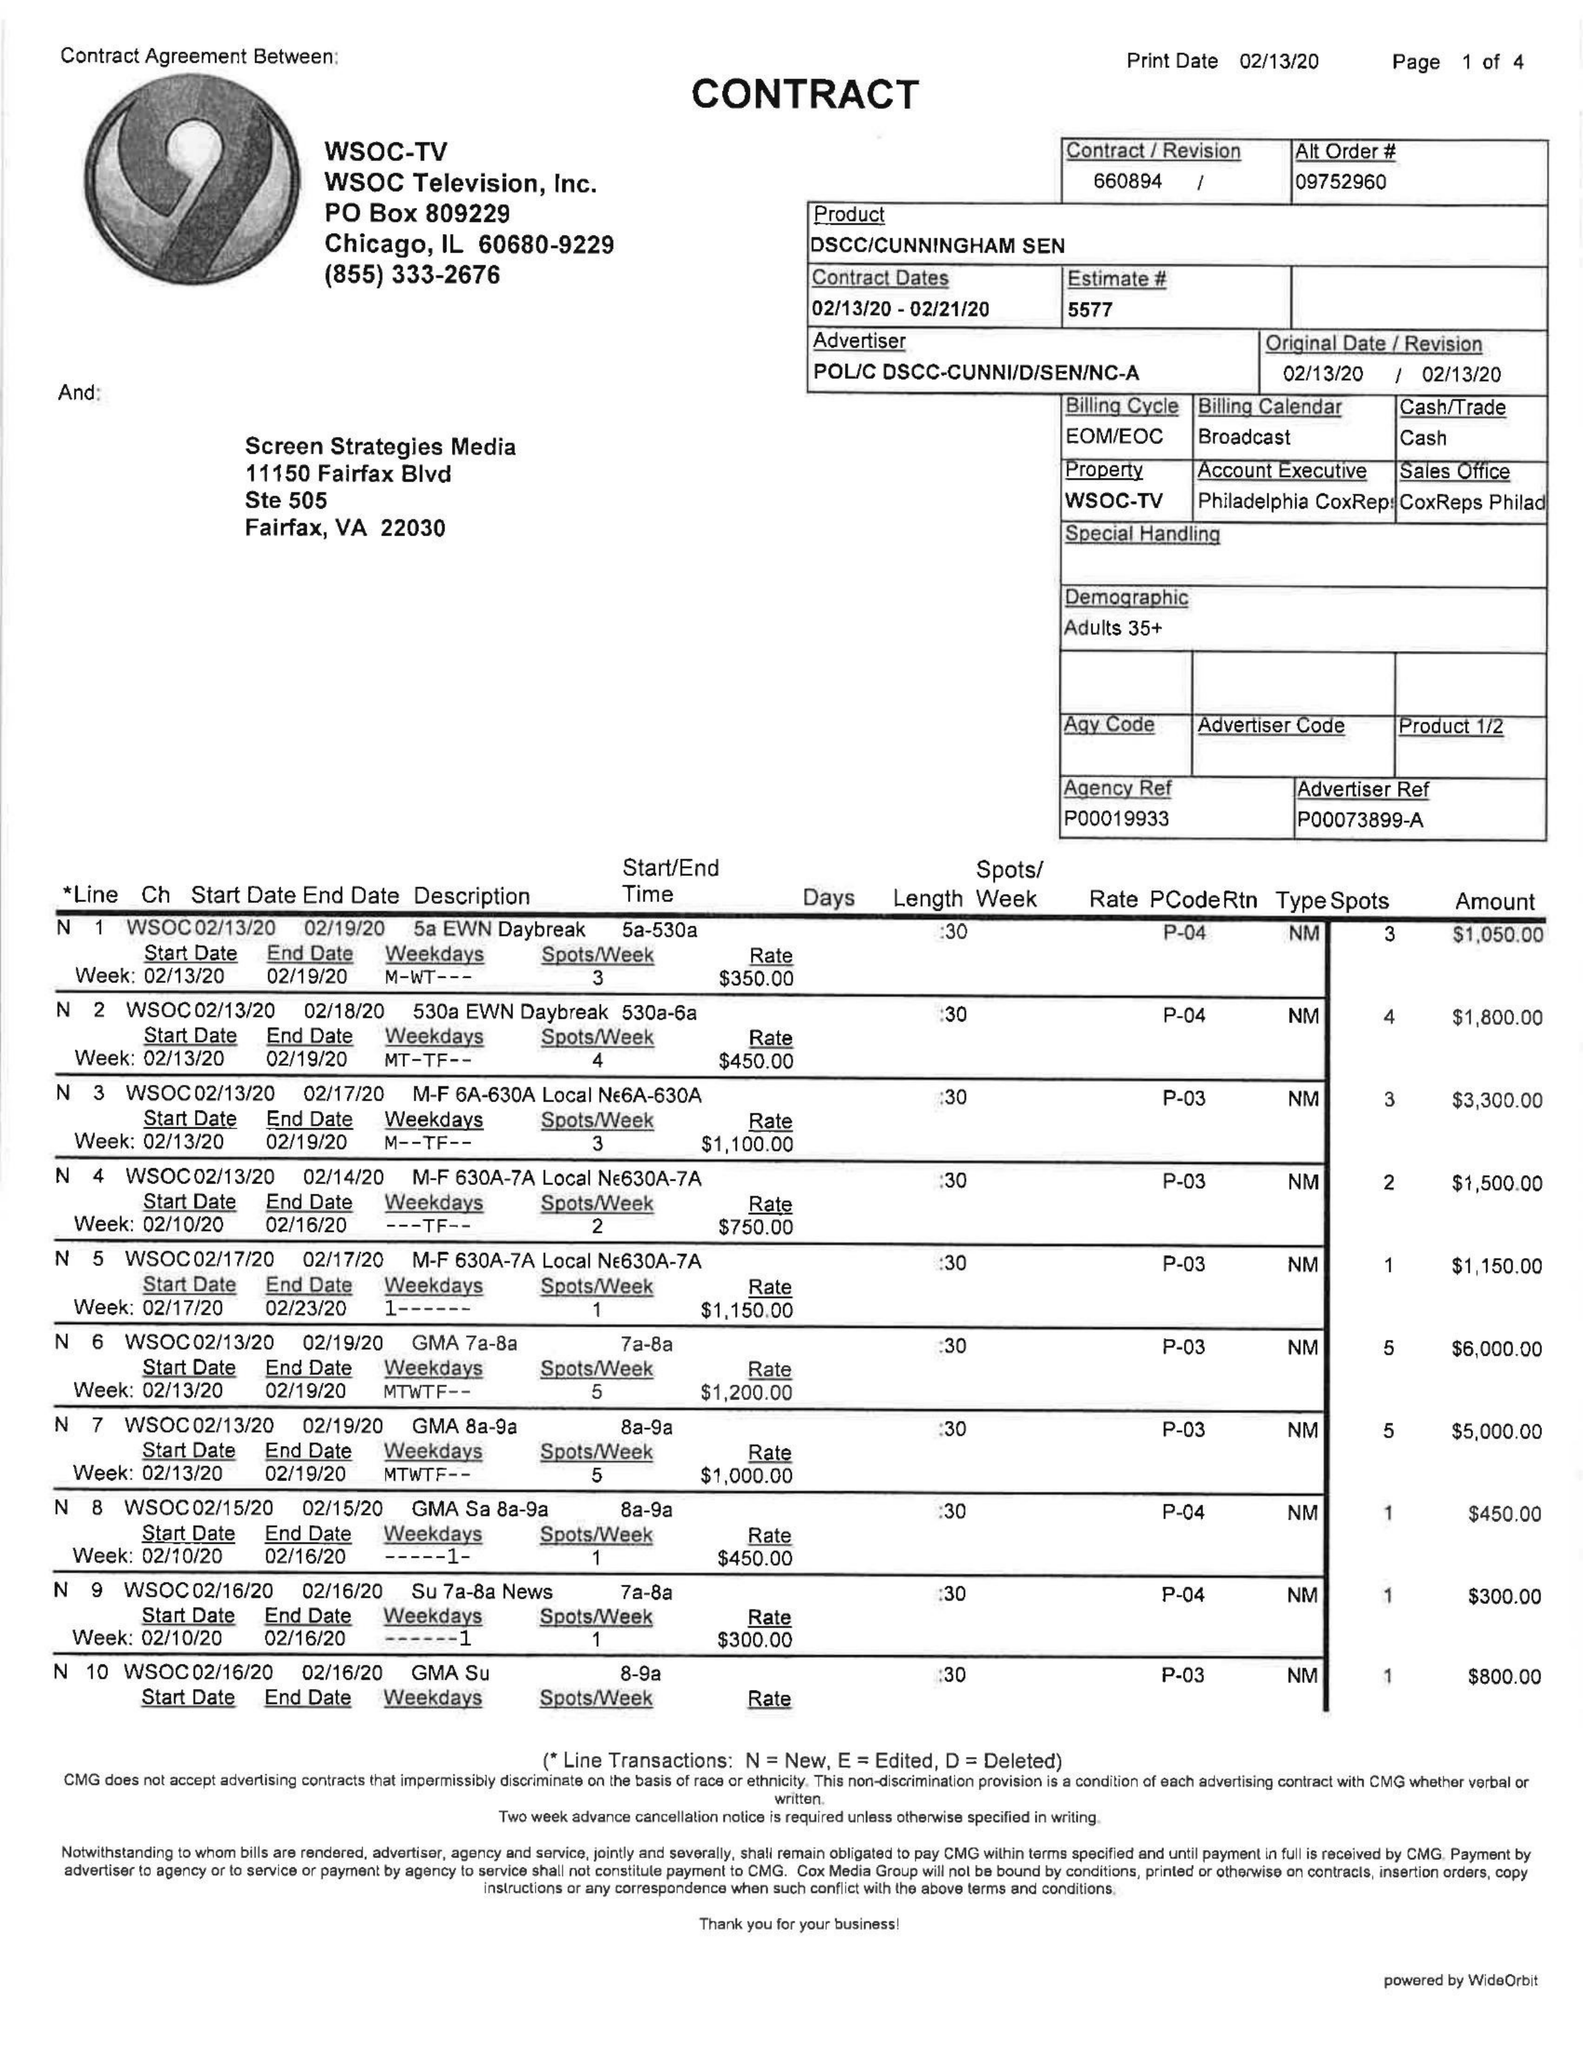What is the value for the flight_to?
Answer the question using a single word or phrase. 02/21/20 